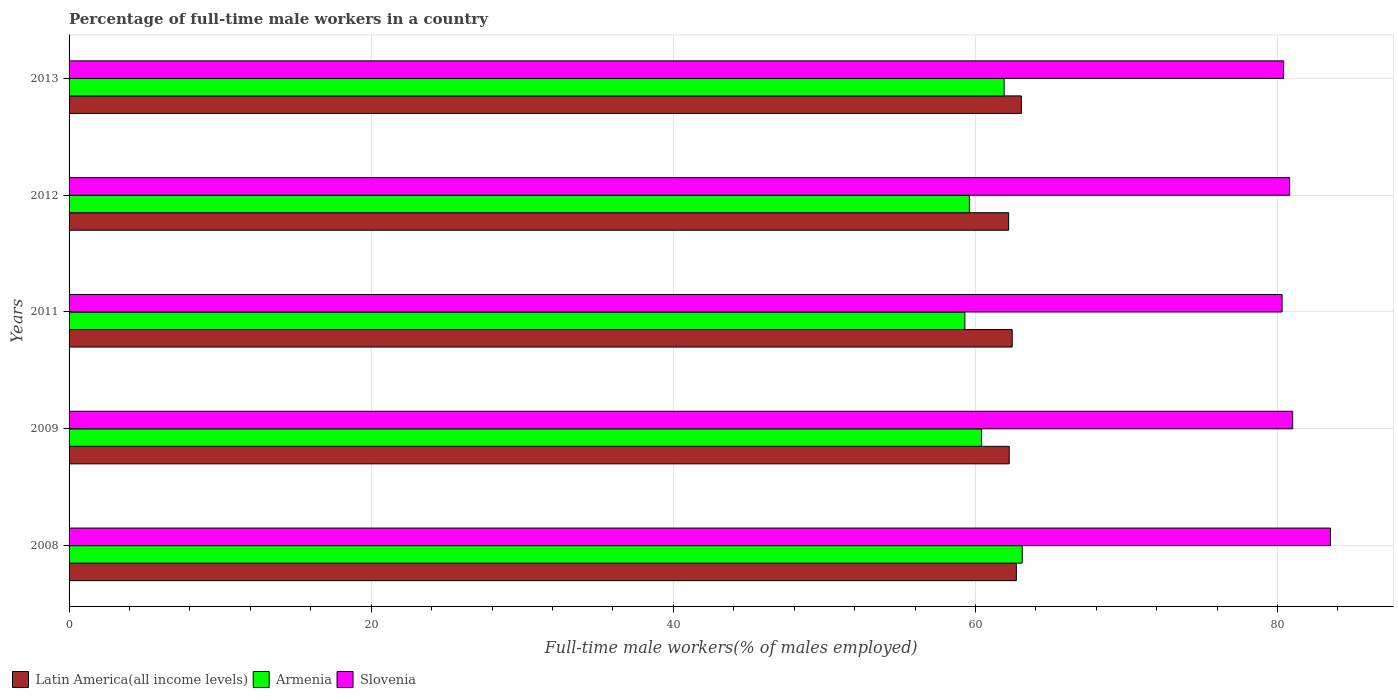How many different coloured bars are there?
Your answer should be compact. 3. Are the number of bars per tick equal to the number of legend labels?
Give a very brief answer. Yes. Are the number of bars on each tick of the Y-axis equal?
Offer a very short reply. Yes. How many bars are there on the 4th tick from the top?
Give a very brief answer. 3. What is the label of the 3rd group of bars from the top?
Keep it short and to the point. 2011. In how many cases, is the number of bars for a given year not equal to the number of legend labels?
Give a very brief answer. 0. What is the percentage of full-time male workers in Latin America(all income levels) in 2011?
Keep it short and to the point. 62.43. Across all years, what is the maximum percentage of full-time male workers in Latin America(all income levels)?
Ensure brevity in your answer.  63.04. Across all years, what is the minimum percentage of full-time male workers in Slovenia?
Give a very brief answer. 80.3. What is the total percentage of full-time male workers in Latin America(all income levels) in the graph?
Keep it short and to the point. 312.62. What is the difference between the percentage of full-time male workers in Armenia in 2011 and that in 2013?
Keep it short and to the point. -2.6. What is the difference between the percentage of full-time male workers in Latin America(all income levels) in 2009 and the percentage of full-time male workers in Armenia in 2011?
Offer a terse response. 2.94. What is the average percentage of full-time male workers in Slovenia per year?
Ensure brevity in your answer.  81.2. In the year 2009, what is the difference between the percentage of full-time male workers in Armenia and percentage of full-time male workers in Latin America(all income levels)?
Give a very brief answer. -1.84. In how many years, is the percentage of full-time male workers in Latin America(all income levels) greater than 28 %?
Your answer should be compact. 5. What is the ratio of the percentage of full-time male workers in Armenia in 2009 to that in 2011?
Your answer should be very brief. 1.02. What is the difference between the highest and the lowest percentage of full-time male workers in Latin America(all income levels)?
Offer a terse response. 0.84. Is the sum of the percentage of full-time male workers in Latin America(all income levels) in 2011 and 2013 greater than the maximum percentage of full-time male workers in Slovenia across all years?
Provide a succinct answer. Yes. What does the 2nd bar from the top in 2011 represents?
Your response must be concise. Armenia. What does the 1st bar from the bottom in 2012 represents?
Your response must be concise. Latin America(all income levels). How many bars are there?
Your answer should be very brief. 15. Are all the bars in the graph horizontal?
Keep it short and to the point. Yes. What is the difference between two consecutive major ticks on the X-axis?
Your answer should be compact. 20. Are the values on the major ticks of X-axis written in scientific E-notation?
Your response must be concise. No. How many legend labels are there?
Your response must be concise. 3. How are the legend labels stacked?
Your answer should be very brief. Horizontal. What is the title of the graph?
Give a very brief answer. Percentage of full-time male workers in a country. What is the label or title of the X-axis?
Provide a succinct answer. Full-time male workers(% of males employed). What is the label or title of the Y-axis?
Give a very brief answer. Years. What is the Full-time male workers(% of males employed) of Latin America(all income levels) in 2008?
Give a very brief answer. 62.71. What is the Full-time male workers(% of males employed) of Armenia in 2008?
Your answer should be very brief. 63.1. What is the Full-time male workers(% of males employed) of Slovenia in 2008?
Your answer should be compact. 83.5. What is the Full-time male workers(% of males employed) of Latin America(all income levels) in 2009?
Your response must be concise. 62.24. What is the Full-time male workers(% of males employed) of Armenia in 2009?
Provide a succinct answer. 60.4. What is the Full-time male workers(% of males employed) in Slovenia in 2009?
Provide a short and direct response. 81. What is the Full-time male workers(% of males employed) in Latin America(all income levels) in 2011?
Offer a terse response. 62.43. What is the Full-time male workers(% of males employed) in Armenia in 2011?
Make the answer very short. 59.3. What is the Full-time male workers(% of males employed) of Slovenia in 2011?
Provide a succinct answer. 80.3. What is the Full-time male workers(% of males employed) in Latin America(all income levels) in 2012?
Ensure brevity in your answer.  62.2. What is the Full-time male workers(% of males employed) of Armenia in 2012?
Make the answer very short. 59.6. What is the Full-time male workers(% of males employed) in Slovenia in 2012?
Your answer should be very brief. 80.8. What is the Full-time male workers(% of males employed) in Latin America(all income levels) in 2013?
Ensure brevity in your answer.  63.04. What is the Full-time male workers(% of males employed) in Armenia in 2013?
Keep it short and to the point. 61.9. What is the Full-time male workers(% of males employed) in Slovenia in 2013?
Offer a terse response. 80.4. Across all years, what is the maximum Full-time male workers(% of males employed) in Latin America(all income levels)?
Offer a very short reply. 63.04. Across all years, what is the maximum Full-time male workers(% of males employed) in Armenia?
Offer a terse response. 63.1. Across all years, what is the maximum Full-time male workers(% of males employed) of Slovenia?
Keep it short and to the point. 83.5. Across all years, what is the minimum Full-time male workers(% of males employed) in Latin America(all income levels)?
Give a very brief answer. 62.2. Across all years, what is the minimum Full-time male workers(% of males employed) of Armenia?
Keep it short and to the point. 59.3. Across all years, what is the minimum Full-time male workers(% of males employed) of Slovenia?
Provide a short and direct response. 80.3. What is the total Full-time male workers(% of males employed) of Latin America(all income levels) in the graph?
Your answer should be compact. 312.62. What is the total Full-time male workers(% of males employed) of Armenia in the graph?
Keep it short and to the point. 304.3. What is the total Full-time male workers(% of males employed) in Slovenia in the graph?
Provide a short and direct response. 406. What is the difference between the Full-time male workers(% of males employed) in Latin America(all income levels) in 2008 and that in 2009?
Your response must be concise. 0.47. What is the difference between the Full-time male workers(% of males employed) of Armenia in 2008 and that in 2009?
Keep it short and to the point. 2.7. What is the difference between the Full-time male workers(% of males employed) in Latin America(all income levels) in 2008 and that in 2011?
Provide a short and direct response. 0.27. What is the difference between the Full-time male workers(% of males employed) of Slovenia in 2008 and that in 2011?
Your response must be concise. 3.2. What is the difference between the Full-time male workers(% of males employed) of Latin America(all income levels) in 2008 and that in 2012?
Make the answer very short. 0.51. What is the difference between the Full-time male workers(% of males employed) in Slovenia in 2008 and that in 2012?
Offer a very short reply. 2.7. What is the difference between the Full-time male workers(% of males employed) of Latin America(all income levels) in 2008 and that in 2013?
Offer a very short reply. -0.33. What is the difference between the Full-time male workers(% of males employed) of Armenia in 2008 and that in 2013?
Offer a terse response. 1.2. What is the difference between the Full-time male workers(% of males employed) in Latin America(all income levels) in 2009 and that in 2011?
Ensure brevity in your answer.  -0.2. What is the difference between the Full-time male workers(% of males employed) of Armenia in 2009 and that in 2011?
Provide a succinct answer. 1.1. What is the difference between the Full-time male workers(% of males employed) in Slovenia in 2009 and that in 2011?
Offer a terse response. 0.7. What is the difference between the Full-time male workers(% of males employed) of Latin America(all income levels) in 2009 and that in 2012?
Ensure brevity in your answer.  0.04. What is the difference between the Full-time male workers(% of males employed) of Latin America(all income levels) in 2009 and that in 2013?
Your answer should be very brief. -0.8. What is the difference between the Full-time male workers(% of males employed) of Armenia in 2009 and that in 2013?
Ensure brevity in your answer.  -1.5. What is the difference between the Full-time male workers(% of males employed) in Slovenia in 2009 and that in 2013?
Ensure brevity in your answer.  0.6. What is the difference between the Full-time male workers(% of males employed) of Latin America(all income levels) in 2011 and that in 2012?
Offer a very short reply. 0.24. What is the difference between the Full-time male workers(% of males employed) in Latin America(all income levels) in 2011 and that in 2013?
Your answer should be very brief. -0.61. What is the difference between the Full-time male workers(% of males employed) in Armenia in 2011 and that in 2013?
Offer a very short reply. -2.6. What is the difference between the Full-time male workers(% of males employed) in Slovenia in 2011 and that in 2013?
Provide a succinct answer. -0.1. What is the difference between the Full-time male workers(% of males employed) in Latin America(all income levels) in 2012 and that in 2013?
Your answer should be compact. -0.84. What is the difference between the Full-time male workers(% of males employed) in Armenia in 2012 and that in 2013?
Give a very brief answer. -2.3. What is the difference between the Full-time male workers(% of males employed) of Latin America(all income levels) in 2008 and the Full-time male workers(% of males employed) of Armenia in 2009?
Offer a very short reply. 2.31. What is the difference between the Full-time male workers(% of males employed) of Latin America(all income levels) in 2008 and the Full-time male workers(% of males employed) of Slovenia in 2009?
Make the answer very short. -18.29. What is the difference between the Full-time male workers(% of males employed) in Armenia in 2008 and the Full-time male workers(% of males employed) in Slovenia in 2009?
Provide a short and direct response. -17.9. What is the difference between the Full-time male workers(% of males employed) in Latin America(all income levels) in 2008 and the Full-time male workers(% of males employed) in Armenia in 2011?
Your answer should be compact. 3.41. What is the difference between the Full-time male workers(% of males employed) of Latin America(all income levels) in 2008 and the Full-time male workers(% of males employed) of Slovenia in 2011?
Make the answer very short. -17.59. What is the difference between the Full-time male workers(% of males employed) of Armenia in 2008 and the Full-time male workers(% of males employed) of Slovenia in 2011?
Your response must be concise. -17.2. What is the difference between the Full-time male workers(% of males employed) in Latin America(all income levels) in 2008 and the Full-time male workers(% of males employed) in Armenia in 2012?
Keep it short and to the point. 3.11. What is the difference between the Full-time male workers(% of males employed) of Latin America(all income levels) in 2008 and the Full-time male workers(% of males employed) of Slovenia in 2012?
Offer a terse response. -18.09. What is the difference between the Full-time male workers(% of males employed) of Armenia in 2008 and the Full-time male workers(% of males employed) of Slovenia in 2012?
Provide a succinct answer. -17.7. What is the difference between the Full-time male workers(% of males employed) of Latin America(all income levels) in 2008 and the Full-time male workers(% of males employed) of Armenia in 2013?
Offer a very short reply. 0.81. What is the difference between the Full-time male workers(% of males employed) of Latin America(all income levels) in 2008 and the Full-time male workers(% of males employed) of Slovenia in 2013?
Offer a very short reply. -17.69. What is the difference between the Full-time male workers(% of males employed) of Armenia in 2008 and the Full-time male workers(% of males employed) of Slovenia in 2013?
Your response must be concise. -17.3. What is the difference between the Full-time male workers(% of males employed) in Latin America(all income levels) in 2009 and the Full-time male workers(% of males employed) in Armenia in 2011?
Provide a succinct answer. 2.94. What is the difference between the Full-time male workers(% of males employed) in Latin America(all income levels) in 2009 and the Full-time male workers(% of males employed) in Slovenia in 2011?
Offer a very short reply. -18.06. What is the difference between the Full-time male workers(% of males employed) in Armenia in 2009 and the Full-time male workers(% of males employed) in Slovenia in 2011?
Your response must be concise. -19.9. What is the difference between the Full-time male workers(% of males employed) in Latin America(all income levels) in 2009 and the Full-time male workers(% of males employed) in Armenia in 2012?
Ensure brevity in your answer.  2.64. What is the difference between the Full-time male workers(% of males employed) in Latin America(all income levels) in 2009 and the Full-time male workers(% of males employed) in Slovenia in 2012?
Keep it short and to the point. -18.56. What is the difference between the Full-time male workers(% of males employed) of Armenia in 2009 and the Full-time male workers(% of males employed) of Slovenia in 2012?
Your answer should be compact. -20.4. What is the difference between the Full-time male workers(% of males employed) of Latin America(all income levels) in 2009 and the Full-time male workers(% of males employed) of Armenia in 2013?
Offer a very short reply. 0.34. What is the difference between the Full-time male workers(% of males employed) in Latin America(all income levels) in 2009 and the Full-time male workers(% of males employed) in Slovenia in 2013?
Your response must be concise. -18.16. What is the difference between the Full-time male workers(% of males employed) in Armenia in 2009 and the Full-time male workers(% of males employed) in Slovenia in 2013?
Ensure brevity in your answer.  -20. What is the difference between the Full-time male workers(% of males employed) in Latin America(all income levels) in 2011 and the Full-time male workers(% of males employed) in Armenia in 2012?
Provide a short and direct response. 2.83. What is the difference between the Full-time male workers(% of males employed) in Latin America(all income levels) in 2011 and the Full-time male workers(% of males employed) in Slovenia in 2012?
Give a very brief answer. -18.37. What is the difference between the Full-time male workers(% of males employed) of Armenia in 2011 and the Full-time male workers(% of males employed) of Slovenia in 2012?
Offer a very short reply. -21.5. What is the difference between the Full-time male workers(% of males employed) in Latin America(all income levels) in 2011 and the Full-time male workers(% of males employed) in Armenia in 2013?
Your response must be concise. 0.53. What is the difference between the Full-time male workers(% of males employed) in Latin America(all income levels) in 2011 and the Full-time male workers(% of males employed) in Slovenia in 2013?
Your response must be concise. -17.97. What is the difference between the Full-time male workers(% of males employed) of Armenia in 2011 and the Full-time male workers(% of males employed) of Slovenia in 2013?
Ensure brevity in your answer.  -21.1. What is the difference between the Full-time male workers(% of males employed) of Latin America(all income levels) in 2012 and the Full-time male workers(% of males employed) of Armenia in 2013?
Your answer should be compact. 0.3. What is the difference between the Full-time male workers(% of males employed) of Latin America(all income levels) in 2012 and the Full-time male workers(% of males employed) of Slovenia in 2013?
Your answer should be compact. -18.2. What is the difference between the Full-time male workers(% of males employed) of Armenia in 2012 and the Full-time male workers(% of males employed) of Slovenia in 2013?
Keep it short and to the point. -20.8. What is the average Full-time male workers(% of males employed) of Latin America(all income levels) per year?
Provide a short and direct response. 62.52. What is the average Full-time male workers(% of males employed) in Armenia per year?
Ensure brevity in your answer.  60.86. What is the average Full-time male workers(% of males employed) in Slovenia per year?
Offer a very short reply. 81.2. In the year 2008, what is the difference between the Full-time male workers(% of males employed) of Latin America(all income levels) and Full-time male workers(% of males employed) of Armenia?
Provide a succinct answer. -0.39. In the year 2008, what is the difference between the Full-time male workers(% of males employed) of Latin America(all income levels) and Full-time male workers(% of males employed) of Slovenia?
Ensure brevity in your answer.  -20.79. In the year 2008, what is the difference between the Full-time male workers(% of males employed) in Armenia and Full-time male workers(% of males employed) in Slovenia?
Provide a short and direct response. -20.4. In the year 2009, what is the difference between the Full-time male workers(% of males employed) of Latin America(all income levels) and Full-time male workers(% of males employed) of Armenia?
Your response must be concise. 1.84. In the year 2009, what is the difference between the Full-time male workers(% of males employed) in Latin America(all income levels) and Full-time male workers(% of males employed) in Slovenia?
Offer a terse response. -18.76. In the year 2009, what is the difference between the Full-time male workers(% of males employed) of Armenia and Full-time male workers(% of males employed) of Slovenia?
Give a very brief answer. -20.6. In the year 2011, what is the difference between the Full-time male workers(% of males employed) in Latin America(all income levels) and Full-time male workers(% of males employed) in Armenia?
Your answer should be very brief. 3.13. In the year 2011, what is the difference between the Full-time male workers(% of males employed) in Latin America(all income levels) and Full-time male workers(% of males employed) in Slovenia?
Give a very brief answer. -17.87. In the year 2011, what is the difference between the Full-time male workers(% of males employed) of Armenia and Full-time male workers(% of males employed) of Slovenia?
Your response must be concise. -21. In the year 2012, what is the difference between the Full-time male workers(% of males employed) of Latin America(all income levels) and Full-time male workers(% of males employed) of Armenia?
Your answer should be very brief. 2.6. In the year 2012, what is the difference between the Full-time male workers(% of males employed) of Latin America(all income levels) and Full-time male workers(% of males employed) of Slovenia?
Your response must be concise. -18.6. In the year 2012, what is the difference between the Full-time male workers(% of males employed) of Armenia and Full-time male workers(% of males employed) of Slovenia?
Ensure brevity in your answer.  -21.2. In the year 2013, what is the difference between the Full-time male workers(% of males employed) in Latin America(all income levels) and Full-time male workers(% of males employed) in Armenia?
Give a very brief answer. 1.14. In the year 2013, what is the difference between the Full-time male workers(% of males employed) of Latin America(all income levels) and Full-time male workers(% of males employed) of Slovenia?
Your response must be concise. -17.36. In the year 2013, what is the difference between the Full-time male workers(% of males employed) of Armenia and Full-time male workers(% of males employed) of Slovenia?
Make the answer very short. -18.5. What is the ratio of the Full-time male workers(% of males employed) in Latin America(all income levels) in 2008 to that in 2009?
Your answer should be compact. 1.01. What is the ratio of the Full-time male workers(% of males employed) in Armenia in 2008 to that in 2009?
Your answer should be compact. 1.04. What is the ratio of the Full-time male workers(% of males employed) of Slovenia in 2008 to that in 2009?
Offer a terse response. 1.03. What is the ratio of the Full-time male workers(% of males employed) in Latin America(all income levels) in 2008 to that in 2011?
Make the answer very short. 1. What is the ratio of the Full-time male workers(% of males employed) of Armenia in 2008 to that in 2011?
Your response must be concise. 1.06. What is the ratio of the Full-time male workers(% of males employed) in Slovenia in 2008 to that in 2011?
Provide a succinct answer. 1.04. What is the ratio of the Full-time male workers(% of males employed) of Latin America(all income levels) in 2008 to that in 2012?
Make the answer very short. 1.01. What is the ratio of the Full-time male workers(% of males employed) of Armenia in 2008 to that in 2012?
Give a very brief answer. 1.06. What is the ratio of the Full-time male workers(% of males employed) in Slovenia in 2008 to that in 2012?
Give a very brief answer. 1.03. What is the ratio of the Full-time male workers(% of males employed) of Latin America(all income levels) in 2008 to that in 2013?
Provide a short and direct response. 0.99. What is the ratio of the Full-time male workers(% of males employed) in Armenia in 2008 to that in 2013?
Ensure brevity in your answer.  1.02. What is the ratio of the Full-time male workers(% of males employed) of Slovenia in 2008 to that in 2013?
Offer a very short reply. 1.04. What is the ratio of the Full-time male workers(% of males employed) of Armenia in 2009 to that in 2011?
Offer a very short reply. 1.02. What is the ratio of the Full-time male workers(% of males employed) in Slovenia in 2009 to that in 2011?
Provide a succinct answer. 1.01. What is the ratio of the Full-time male workers(% of males employed) in Armenia in 2009 to that in 2012?
Offer a terse response. 1.01. What is the ratio of the Full-time male workers(% of males employed) of Latin America(all income levels) in 2009 to that in 2013?
Provide a succinct answer. 0.99. What is the ratio of the Full-time male workers(% of males employed) in Armenia in 2009 to that in 2013?
Offer a very short reply. 0.98. What is the ratio of the Full-time male workers(% of males employed) in Slovenia in 2009 to that in 2013?
Offer a very short reply. 1.01. What is the ratio of the Full-time male workers(% of males employed) in Latin America(all income levels) in 2011 to that in 2012?
Offer a very short reply. 1. What is the ratio of the Full-time male workers(% of males employed) of Slovenia in 2011 to that in 2012?
Ensure brevity in your answer.  0.99. What is the ratio of the Full-time male workers(% of males employed) in Latin America(all income levels) in 2011 to that in 2013?
Your answer should be very brief. 0.99. What is the ratio of the Full-time male workers(% of males employed) in Armenia in 2011 to that in 2013?
Provide a succinct answer. 0.96. What is the ratio of the Full-time male workers(% of males employed) of Slovenia in 2011 to that in 2013?
Keep it short and to the point. 1. What is the ratio of the Full-time male workers(% of males employed) of Latin America(all income levels) in 2012 to that in 2013?
Offer a terse response. 0.99. What is the ratio of the Full-time male workers(% of males employed) in Armenia in 2012 to that in 2013?
Offer a terse response. 0.96. What is the difference between the highest and the second highest Full-time male workers(% of males employed) of Latin America(all income levels)?
Provide a succinct answer. 0.33. What is the difference between the highest and the lowest Full-time male workers(% of males employed) in Latin America(all income levels)?
Make the answer very short. 0.84. What is the difference between the highest and the lowest Full-time male workers(% of males employed) in Armenia?
Your answer should be very brief. 3.8. What is the difference between the highest and the lowest Full-time male workers(% of males employed) in Slovenia?
Provide a succinct answer. 3.2. 